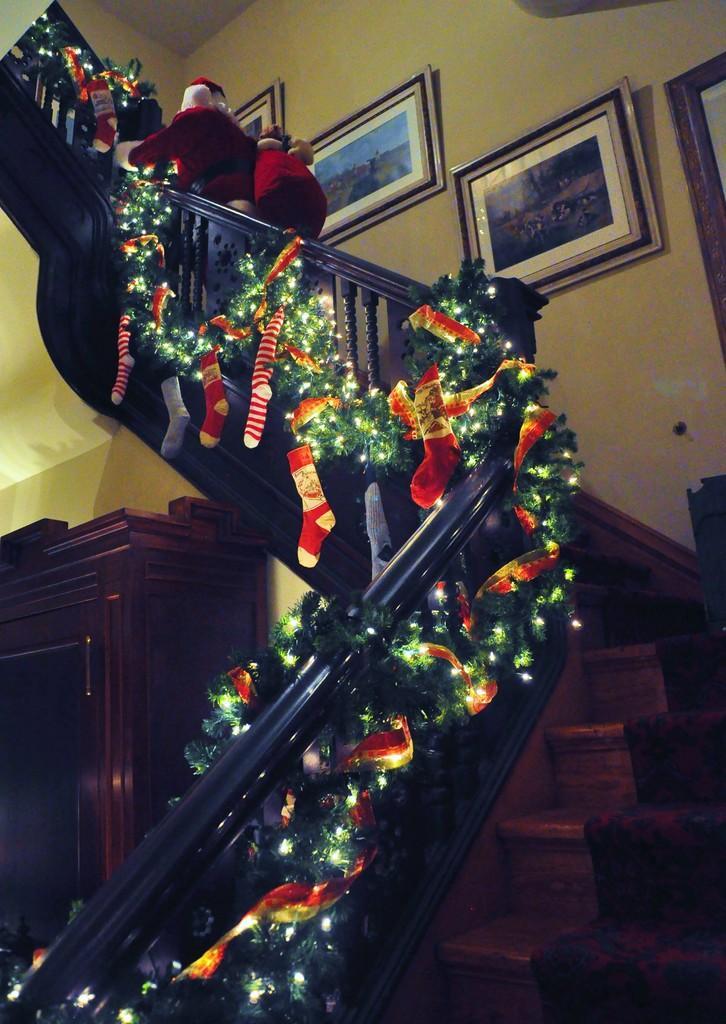Please provide a concise description of this image. In this image, we can see stairs and there are some people wearing costumes and we can see decor items on the railing. In the background, there are frames on the wall and we can see a cupboard. 